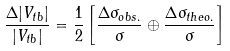<formula> <loc_0><loc_0><loc_500><loc_500>\frac { \Delta | V _ { t b } | } { | V _ { t b } | } = \frac { 1 } { 2 } \left [ \frac { \Delta \sigma _ { o b s . } } { \sigma } \oplus \frac { \Delta \sigma _ { t h e o . } } { \sigma } \right ]</formula> 